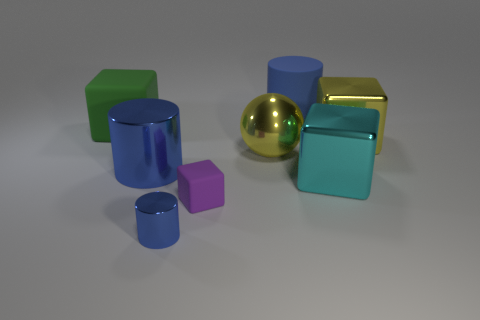How many objects in total are there in the image, and what colors are they? There are seven objects in the image. Starting from the left, there is a green cube, a blue cylinder, a purple cube, a golden sphere, a teal cube, a reflective golden cube, and a smaller blue cylinder. 